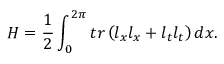Convert formula to latex. <formula><loc_0><loc_0><loc_500><loc_500>H = \frac { 1 } { 2 } \int _ { 0 } ^ { 2 \pi } t r \left ( l _ { x } l _ { x } + l _ { t } l _ { t } \right ) d x .</formula> 